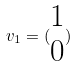<formula> <loc_0><loc_0><loc_500><loc_500>v _ { 1 } = ( \begin{matrix} 1 \\ 0 \end{matrix} )</formula> 